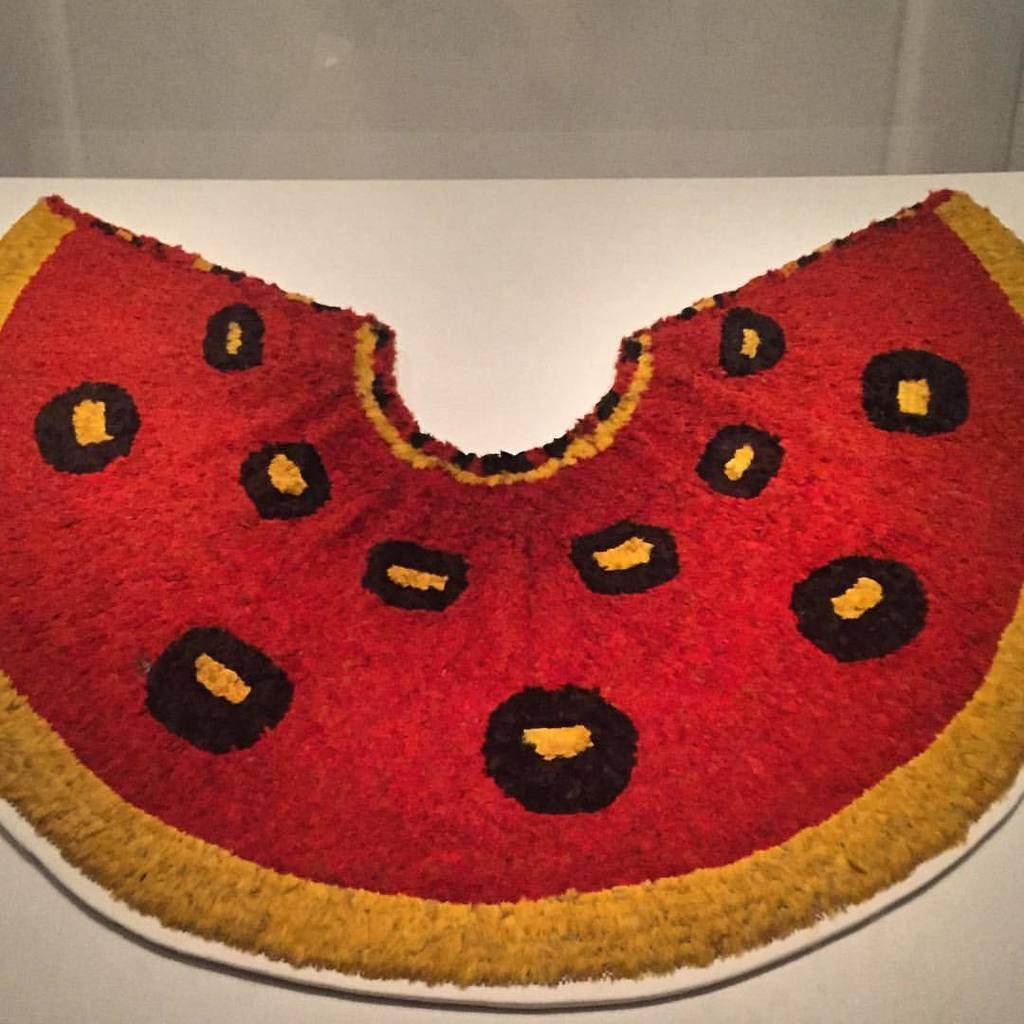What object is present in the image related to a doorway? There is a doormat in the image. What shape does the doormat have? The doormat is in the shape of a watermelon slice. What color is the doormat? The doormat is in red color. What type of feast is being held on the doormat in the image? There is no feast or any indication of a gathering in the image; it only features a doormat in the shape of a watermelon slice. Is the doormat being used as a symbol of protest in the image? There is no indication of protest or any political statement in the image; it only features a doormat in the shape of a watermelon slice. 